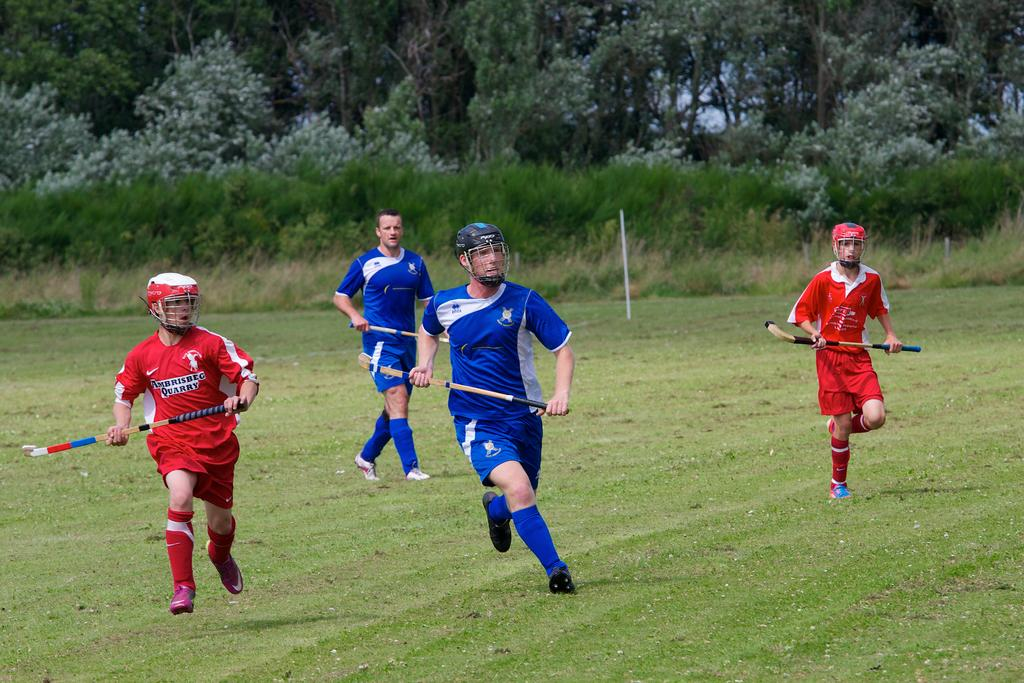<image>
Summarize the visual content of the image. An athlete in red whose shirt mentions a quarry runs in a field. 